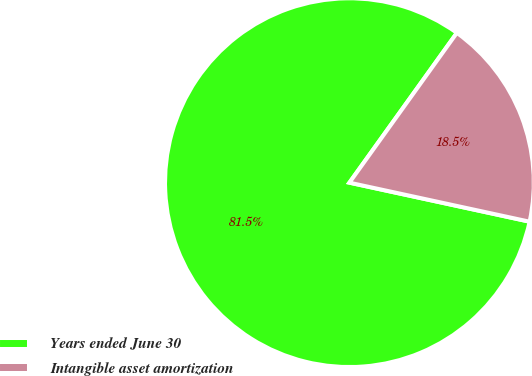Convert chart to OTSL. <chart><loc_0><loc_0><loc_500><loc_500><pie_chart><fcel>Years ended June 30<fcel>Intangible asset amortization<nl><fcel>81.51%<fcel>18.49%<nl></chart> 